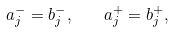Convert formula to latex. <formula><loc_0><loc_0><loc_500><loc_500>a _ { j } ^ { - } = b _ { j } ^ { - } , \quad a _ { j } ^ { + } = b _ { j } ^ { + } ,</formula> 